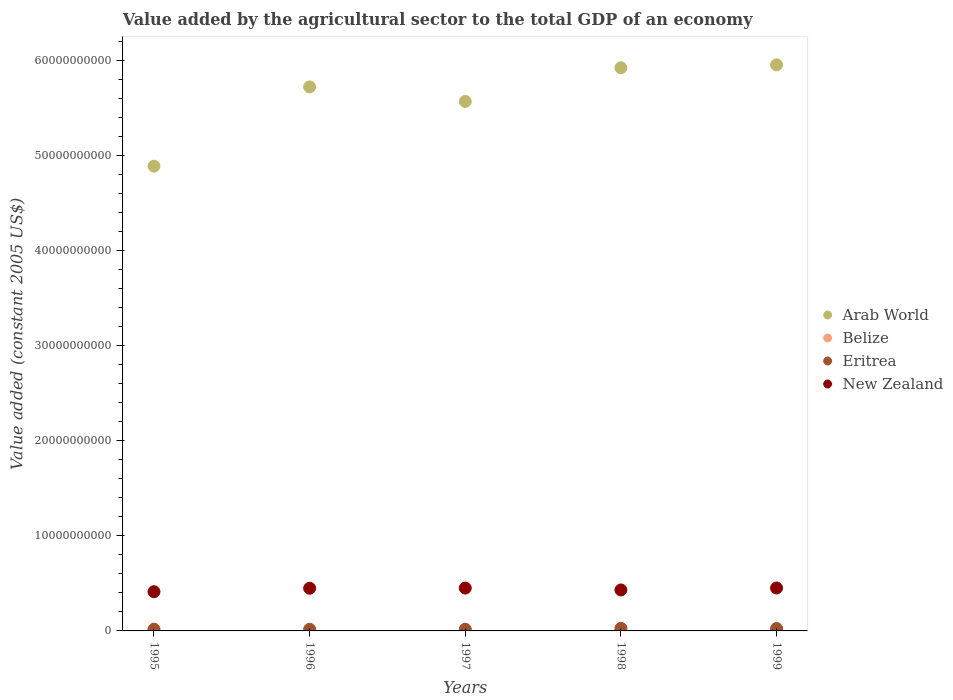How many different coloured dotlines are there?
Your response must be concise. 4. Is the number of dotlines equal to the number of legend labels?
Offer a very short reply. Yes. What is the value added by the agricultural sector in Arab World in 1996?
Offer a terse response. 5.73e+1. Across all years, what is the maximum value added by the agricultural sector in New Zealand?
Keep it short and to the point. 4.52e+09. Across all years, what is the minimum value added by the agricultural sector in Belize?
Your answer should be compact. 6.53e+07. In which year was the value added by the agricultural sector in Belize minimum?
Make the answer very short. 1995. What is the total value added by the agricultural sector in Eritrea in the graph?
Ensure brevity in your answer.  1.06e+09. What is the difference between the value added by the agricultural sector in Belize in 1996 and that in 1999?
Provide a short and direct response. -1.47e+07. What is the difference between the value added by the agricultural sector in New Zealand in 1998 and the value added by the agricultural sector in Arab World in 1999?
Give a very brief answer. -5.53e+1. What is the average value added by the agricultural sector in Arab World per year?
Your answer should be very brief. 5.62e+1. In the year 1998, what is the difference between the value added by the agricultural sector in Eritrea and value added by the agricultural sector in New Zealand?
Offer a terse response. -4.04e+09. What is the ratio of the value added by the agricultural sector in Eritrea in 1996 to that in 1998?
Your answer should be compact. 0.63. Is the value added by the agricultural sector in Arab World in 1997 less than that in 1999?
Your answer should be compact. Yes. What is the difference between the highest and the second highest value added by the agricultural sector in Belize?
Offer a very short reply. 8.30e+06. What is the difference between the highest and the lowest value added by the agricultural sector in New Zealand?
Your response must be concise. 3.92e+08. Is the sum of the value added by the agricultural sector in New Zealand in 1996 and 1998 greater than the maximum value added by the agricultural sector in Belize across all years?
Your answer should be compact. Yes. Is the value added by the agricultural sector in New Zealand strictly greater than the value added by the agricultural sector in Eritrea over the years?
Give a very brief answer. Yes. How many dotlines are there?
Provide a succinct answer. 4. Does the graph contain grids?
Offer a terse response. No. Where does the legend appear in the graph?
Provide a short and direct response. Center right. How many legend labels are there?
Your response must be concise. 4. How are the legend labels stacked?
Make the answer very short. Vertical. What is the title of the graph?
Your answer should be very brief. Value added by the agricultural sector to the total GDP of an economy. Does "Burundi" appear as one of the legend labels in the graph?
Provide a succinct answer. No. What is the label or title of the X-axis?
Ensure brevity in your answer.  Years. What is the label or title of the Y-axis?
Your answer should be compact. Value added (constant 2005 US$). What is the Value added (constant 2005 US$) in Arab World in 1995?
Your answer should be very brief. 4.89e+1. What is the Value added (constant 2005 US$) in Belize in 1995?
Provide a succinct answer. 6.53e+07. What is the Value added (constant 2005 US$) in Eritrea in 1995?
Provide a succinct answer. 1.85e+08. What is the Value added (constant 2005 US$) in New Zealand in 1995?
Give a very brief answer. 4.13e+09. What is the Value added (constant 2005 US$) of Arab World in 1996?
Provide a succinct answer. 5.73e+1. What is the Value added (constant 2005 US$) in Belize in 1996?
Offer a terse response. 7.01e+07. What is the Value added (constant 2005 US$) in Eritrea in 1996?
Give a very brief answer. 1.74e+08. What is the Value added (constant 2005 US$) in New Zealand in 1996?
Make the answer very short. 4.49e+09. What is the Value added (constant 2005 US$) in Arab World in 1997?
Keep it short and to the point. 5.57e+1. What is the Value added (constant 2005 US$) of Belize in 1997?
Your response must be concise. 7.47e+07. What is the Value added (constant 2005 US$) of Eritrea in 1997?
Give a very brief answer. 1.75e+08. What is the Value added (constant 2005 US$) in New Zealand in 1997?
Give a very brief answer. 4.51e+09. What is the Value added (constant 2005 US$) of Arab World in 1998?
Your response must be concise. 5.93e+1. What is the Value added (constant 2005 US$) in Belize in 1998?
Your answer should be very brief. 7.64e+07. What is the Value added (constant 2005 US$) in Eritrea in 1998?
Offer a terse response. 2.75e+08. What is the Value added (constant 2005 US$) in New Zealand in 1998?
Ensure brevity in your answer.  4.31e+09. What is the Value added (constant 2005 US$) of Arab World in 1999?
Provide a succinct answer. 5.96e+1. What is the Value added (constant 2005 US$) in Belize in 1999?
Provide a succinct answer. 8.47e+07. What is the Value added (constant 2005 US$) of Eritrea in 1999?
Provide a short and direct response. 2.54e+08. What is the Value added (constant 2005 US$) of New Zealand in 1999?
Provide a short and direct response. 4.52e+09. Across all years, what is the maximum Value added (constant 2005 US$) of Arab World?
Ensure brevity in your answer.  5.96e+1. Across all years, what is the maximum Value added (constant 2005 US$) in Belize?
Give a very brief answer. 8.47e+07. Across all years, what is the maximum Value added (constant 2005 US$) in Eritrea?
Provide a succinct answer. 2.75e+08. Across all years, what is the maximum Value added (constant 2005 US$) of New Zealand?
Offer a very short reply. 4.52e+09. Across all years, what is the minimum Value added (constant 2005 US$) in Arab World?
Give a very brief answer. 4.89e+1. Across all years, what is the minimum Value added (constant 2005 US$) of Belize?
Your response must be concise. 6.53e+07. Across all years, what is the minimum Value added (constant 2005 US$) in Eritrea?
Offer a very short reply. 1.74e+08. Across all years, what is the minimum Value added (constant 2005 US$) in New Zealand?
Your response must be concise. 4.13e+09. What is the total Value added (constant 2005 US$) in Arab World in the graph?
Provide a short and direct response. 2.81e+11. What is the total Value added (constant 2005 US$) in Belize in the graph?
Give a very brief answer. 3.71e+08. What is the total Value added (constant 2005 US$) of Eritrea in the graph?
Provide a short and direct response. 1.06e+09. What is the total Value added (constant 2005 US$) of New Zealand in the graph?
Keep it short and to the point. 2.20e+1. What is the difference between the Value added (constant 2005 US$) in Arab World in 1995 and that in 1996?
Offer a very short reply. -8.34e+09. What is the difference between the Value added (constant 2005 US$) in Belize in 1995 and that in 1996?
Keep it short and to the point. -4.76e+06. What is the difference between the Value added (constant 2005 US$) in Eritrea in 1995 and that in 1996?
Your answer should be very brief. 1.06e+07. What is the difference between the Value added (constant 2005 US$) in New Zealand in 1995 and that in 1996?
Your answer should be very brief. -3.64e+08. What is the difference between the Value added (constant 2005 US$) of Arab World in 1995 and that in 1997?
Your response must be concise. -6.81e+09. What is the difference between the Value added (constant 2005 US$) in Belize in 1995 and that in 1997?
Offer a very short reply. -9.42e+06. What is the difference between the Value added (constant 2005 US$) in Eritrea in 1995 and that in 1997?
Give a very brief answer. 9.75e+06. What is the difference between the Value added (constant 2005 US$) of New Zealand in 1995 and that in 1997?
Ensure brevity in your answer.  -3.82e+08. What is the difference between the Value added (constant 2005 US$) in Arab World in 1995 and that in 1998?
Make the answer very short. -1.04e+1. What is the difference between the Value added (constant 2005 US$) of Belize in 1995 and that in 1998?
Your answer should be compact. -1.11e+07. What is the difference between the Value added (constant 2005 US$) of Eritrea in 1995 and that in 1998?
Offer a very short reply. -9.05e+07. What is the difference between the Value added (constant 2005 US$) in New Zealand in 1995 and that in 1998?
Your answer should be compact. -1.86e+08. What is the difference between the Value added (constant 2005 US$) of Arab World in 1995 and that in 1999?
Provide a short and direct response. -1.07e+1. What is the difference between the Value added (constant 2005 US$) in Belize in 1995 and that in 1999?
Provide a short and direct response. -1.94e+07. What is the difference between the Value added (constant 2005 US$) of Eritrea in 1995 and that in 1999?
Provide a short and direct response. -6.95e+07. What is the difference between the Value added (constant 2005 US$) of New Zealand in 1995 and that in 1999?
Keep it short and to the point. -3.92e+08. What is the difference between the Value added (constant 2005 US$) in Arab World in 1996 and that in 1997?
Provide a short and direct response. 1.53e+09. What is the difference between the Value added (constant 2005 US$) in Belize in 1996 and that in 1997?
Keep it short and to the point. -4.65e+06. What is the difference between the Value added (constant 2005 US$) of Eritrea in 1996 and that in 1997?
Your answer should be compact. -8.89e+05. What is the difference between the Value added (constant 2005 US$) in New Zealand in 1996 and that in 1997?
Ensure brevity in your answer.  -1.73e+07. What is the difference between the Value added (constant 2005 US$) of Arab World in 1996 and that in 1998?
Your answer should be very brief. -2.02e+09. What is the difference between the Value added (constant 2005 US$) of Belize in 1996 and that in 1998?
Ensure brevity in your answer.  -6.36e+06. What is the difference between the Value added (constant 2005 US$) of Eritrea in 1996 and that in 1998?
Ensure brevity in your answer.  -1.01e+08. What is the difference between the Value added (constant 2005 US$) in New Zealand in 1996 and that in 1998?
Your answer should be very brief. 1.79e+08. What is the difference between the Value added (constant 2005 US$) in Arab World in 1996 and that in 1999?
Offer a very short reply. -2.32e+09. What is the difference between the Value added (constant 2005 US$) of Belize in 1996 and that in 1999?
Offer a terse response. -1.47e+07. What is the difference between the Value added (constant 2005 US$) in Eritrea in 1996 and that in 1999?
Ensure brevity in your answer.  -8.01e+07. What is the difference between the Value added (constant 2005 US$) of New Zealand in 1996 and that in 1999?
Your answer should be very brief. -2.74e+07. What is the difference between the Value added (constant 2005 US$) of Arab World in 1997 and that in 1998?
Ensure brevity in your answer.  -3.55e+09. What is the difference between the Value added (constant 2005 US$) of Belize in 1997 and that in 1998?
Offer a very short reply. -1.71e+06. What is the difference between the Value added (constant 2005 US$) of Eritrea in 1997 and that in 1998?
Ensure brevity in your answer.  -1.00e+08. What is the difference between the Value added (constant 2005 US$) of New Zealand in 1997 and that in 1998?
Your response must be concise. 1.96e+08. What is the difference between the Value added (constant 2005 US$) of Arab World in 1997 and that in 1999?
Provide a short and direct response. -3.86e+09. What is the difference between the Value added (constant 2005 US$) of Belize in 1997 and that in 1999?
Your answer should be very brief. -1.00e+07. What is the difference between the Value added (constant 2005 US$) in Eritrea in 1997 and that in 1999?
Your answer should be very brief. -7.92e+07. What is the difference between the Value added (constant 2005 US$) of New Zealand in 1997 and that in 1999?
Your answer should be compact. -1.00e+07. What is the difference between the Value added (constant 2005 US$) of Arab World in 1998 and that in 1999?
Provide a succinct answer. -3.03e+08. What is the difference between the Value added (constant 2005 US$) of Belize in 1998 and that in 1999?
Provide a succinct answer. -8.30e+06. What is the difference between the Value added (constant 2005 US$) in Eritrea in 1998 and that in 1999?
Your response must be concise. 2.11e+07. What is the difference between the Value added (constant 2005 US$) of New Zealand in 1998 and that in 1999?
Give a very brief answer. -2.06e+08. What is the difference between the Value added (constant 2005 US$) of Arab World in 1995 and the Value added (constant 2005 US$) of Belize in 1996?
Your answer should be very brief. 4.89e+1. What is the difference between the Value added (constant 2005 US$) in Arab World in 1995 and the Value added (constant 2005 US$) in Eritrea in 1996?
Ensure brevity in your answer.  4.87e+1. What is the difference between the Value added (constant 2005 US$) of Arab World in 1995 and the Value added (constant 2005 US$) of New Zealand in 1996?
Offer a very short reply. 4.44e+1. What is the difference between the Value added (constant 2005 US$) in Belize in 1995 and the Value added (constant 2005 US$) in Eritrea in 1996?
Your answer should be very brief. -1.09e+08. What is the difference between the Value added (constant 2005 US$) in Belize in 1995 and the Value added (constant 2005 US$) in New Zealand in 1996?
Your answer should be compact. -4.43e+09. What is the difference between the Value added (constant 2005 US$) in Eritrea in 1995 and the Value added (constant 2005 US$) in New Zealand in 1996?
Provide a short and direct response. -4.31e+09. What is the difference between the Value added (constant 2005 US$) of Arab World in 1995 and the Value added (constant 2005 US$) of Belize in 1997?
Ensure brevity in your answer.  4.88e+1. What is the difference between the Value added (constant 2005 US$) of Arab World in 1995 and the Value added (constant 2005 US$) of Eritrea in 1997?
Provide a short and direct response. 4.87e+1. What is the difference between the Value added (constant 2005 US$) in Arab World in 1995 and the Value added (constant 2005 US$) in New Zealand in 1997?
Ensure brevity in your answer.  4.44e+1. What is the difference between the Value added (constant 2005 US$) in Belize in 1995 and the Value added (constant 2005 US$) in Eritrea in 1997?
Give a very brief answer. -1.10e+08. What is the difference between the Value added (constant 2005 US$) of Belize in 1995 and the Value added (constant 2005 US$) of New Zealand in 1997?
Make the answer very short. -4.44e+09. What is the difference between the Value added (constant 2005 US$) in Eritrea in 1995 and the Value added (constant 2005 US$) in New Zealand in 1997?
Give a very brief answer. -4.32e+09. What is the difference between the Value added (constant 2005 US$) in Arab World in 1995 and the Value added (constant 2005 US$) in Belize in 1998?
Offer a terse response. 4.88e+1. What is the difference between the Value added (constant 2005 US$) in Arab World in 1995 and the Value added (constant 2005 US$) in Eritrea in 1998?
Make the answer very short. 4.86e+1. What is the difference between the Value added (constant 2005 US$) in Arab World in 1995 and the Value added (constant 2005 US$) in New Zealand in 1998?
Your answer should be compact. 4.46e+1. What is the difference between the Value added (constant 2005 US$) of Belize in 1995 and the Value added (constant 2005 US$) of Eritrea in 1998?
Provide a succinct answer. -2.10e+08. What is the difference between the Value added (constant 2005 US$) of Belize in 1995 and the Value added (constant 2005 US$) of New Zealand in 1998?
Your answer should be very brief. -4.25e+09. What is the difference between the Value added (constant 2005 US$) of Eritrea in 1995 and the Value added (constant 2005 US$) of New Zealand in 1998?
Offer a very short reply. -4.13e+09. What is the difference between the Value added (constant 2005 US$) of Arab World in 1995 and the Value added (constant 2005 US$) of Belize in 1999?
Make the answer very short. 4.88e+1. What is the difference between the Value added (constant 2005 US$) in Arab World in 1995 and the Value added (constant 2005 US$) in Eritrea in 1999?
Your answer should be very brief. 4.87e+1. What is the difference between the Value added (constant 2005 US$) of Arab World in 1995 and the Value added (constant 2005 US$) of New Zealand in 1999?
Keep it short and to the point. 4.44e+1. What is the difference between the Value added (constant 2005 US$) of Belize in 1995 and the Value added (constant 2005 US$) of Eritrea in 1999?
Your answer should be very brief. -1.89e+08. What is the difference between the Value added (constant 2005 US$) in Belize in 1995 and the Value added (constant 2005 US$) in New Zealand in 1999?
Keep it short and to the point. -4.45e+09. What is the difference between the Value added (constant 2005 US$) in Eritrea in 1995 and the Value added (constant 2005 US$) in New Zealand in 1999?
Provide a short and direct response. -4.33e+09. What is the difference between the Value added (constant 2005 US$) of Arab World in 1996 and the Value added (constant 2005 US$) of Belize in 1997?
Provide a short and direct response. 5.72e+1. What is the difference between the Value added (constant 2005 US$) in Arab World in 1996 and the Value added (constant 2005 US$) in Eritrea in 1997?
Your response must be concise. 5.71e+1. What is the difference between the Value added (constant 2005 US$) of Arab World in 1996 and the Value added (constant 2005 US$) of New Zealand in 1997?
Make the answer very short. 5.28e+1. What is the difference between the Value added (constant 2005 US$) of Belize in 1996 and the Value added (constant 2005 US$) of Eritrea in 1997?
Offer a very short reply. -1.05e+08. What is the difference between the Value added (constant 2005 US$) in Belize in 1996 and the Value added (constant 2005 US$) in New Zealand in 1997?
Ensure brevity in your answer.  -4.44e+09. What is the difference between the Value added (constant 2005 US$) in Eritrea in 1996 and the Value added (constant 2005 US$) in New Zealand in 1997?
Keep it short and to the point. -4.34e+09. What is the difference between the Value added (constant 2005 US$) of Arab World in 1996 and the Value added (constant 2005 US$) of Belize in 1998?
Offer a very short reply. 5.72e+1. What is the difference between the Value added (constant 2005 US$) in Arab World in 1996 and the Value added (constant 2005 US$) in Eritrea in 1998?
Give a very brief answer. 5.70e+1. What is the difference between the Value added (constant 2005 US$) of Arab World in 1996 and the Value added (constant 2005 US$) of New Zealand in 1998?
Make the answer very short. 5.29e+1. What is the difference between the Value added (constant 2005 US$) of Belize in 1996 and the Value added (constant 2005 US$) of Eritrea in 1998?
Offer a very short reply. -2.05e+08. What is the difference between the Value added (constant 2005 US$) of Belize in 1996 and the Value added (constant 2005 US$) of New Zealand in 1998?
Make the answer very short. -4.24e+09. What is the difference between the Value added (constant 2005 US$) in Eritrea in 1996 and the Value added (constant 2005 US$) in New Zealand in 1998?
Keep it short and to the point. -4.14e+09. What is the difference between the Value added (constant 2005 US$) in Arab World in 1996 and the Value added (constant 2005 US$) in Belize in 1999?
Your response must be concise. 5.72e+1. What is the difference between the Value added (constant 2005 US$) of Arab World in 1996 and the Value added (constant 2005 US$) of Eritrea in 1999?
Provide a succinct answer. 5.70e+1. What is the difference between the Value added (constant 2005 US$) in Arab World in 1996 and the Value added (constant 2005 US$) in New Zealand in 1999?
Give a very brief answer. 5.27e+1. What is the difference between the Value added (constant 2005 US$) of Belize in 1996 and the Value added (constant 2005 US$) of Eritrea in 1999?
Make the answer very short. -1.84e+08. What is the difference between the Value added (constant 2005 US$) in Belize in 1996 and the Value added (constant 2005 US$) in New Zealand in 1999?
Your response must be concise. -4.45e+09. What is the difference between the Value added (constant 2005 US$) in Eritrea in 1996 and the Value added (constant 2005 US$) in New Zealand in 1999?
Provide a short and direct response. -4.35e+09. What is the difference between the Value added (constant 2005 US$) in Arab World in 1997 and the Value added (constant 2005 US$) in Belize in 1998?
Your answer should be compact. 5.57e+1. What is the difference between the Value added (constant 2005 US$) in Arab World in 1997 and the Value added (constant 2005 US$) in Eritrea in 1998?
Offer a very short reply. 5.55e+1. What is the difference between the Value added (constant 2005 US$) in Arab World in 1997 and the Value added (constant 2005 US$) in New Zealand in 1998?
Provide a short and direct response. 5.14e+1. What is the difference between the Value added (constant 2005 US$) in Belize in 1997 and the Value added (constant 2005 US$) in Eritrea in 1998?
Provide a succinct answer. -2.00e+08. What is the difference between the Value added (constant 2005 US$) of Belize in 1997 and the Value added (constant 2005 US$) of New Zealand in 1998?
Provide a succinct answer. -4.24e+09. What is the difference between the Value added (constant 2005 US$) in Eritrea in 1997 and the Value added (constant 2005 US$) in New Zealand in 1998?
Offer a very short reply. -4.14e+09. What is the difference between the Value added (constant 2005 US$) in Arab World in 1997 and the Value added (constant 2005 US$) in Belize in 1999?
Give a very brief answer. 5.56e+1. What is the difference between the Value added (constant 2005 US$) of Arab World in 1997 and the Value added (constant 2005 US$) of Eritrea in 1999?
Make the answer very short. 5.55e+1. What is the difference between the Value added (constant 2005 US$) in Arab World in 1997 and the Value added (constant 2005 US$) in New Zealand in 1999?
Ensure brevity in your answer.  5.12e+1. What is the difference between the Value added (constant 2005 US$) in Belize in 1997 and the Value added (constant 2005 US$) in Eritrea in 1999?
Make the answer very short. -1.79e+08. What is the difference between the Value added (constant 2005 US$) of Belize in 1997 and the Value added (constant 2005 US$) of New Zealand in 1999?
Provide a short and direct response. -4.44e+09. What is the difference between the Value added (constant 2005 US$) in Eritrea in 1997 and the Value added (constant 2005 US$) in New Zealand in 1999?
Your answer should be compact. -4.34e+09. What is the difference between the Value added (constant 2005 US$) in Arab World in 1998 and the Value added (constant 2005 US$) in Belize in 1999?
Provide a succinct answer. 5.92e+1. What is the difference between the Value added (constant 2005 US$) of Arab World in 1998 and the Value added (constant 2005 US$) of Eritrea in 1999?
Your answer should be very brief. 5.90e+1. What is the difference between the Value added (constant 2005 US$) of Arab World in 1998 and the Value added (constant 2005 US$) of New Zealand in 1999?
Make the answer very short. 5.48e+1. What is the difference between the Value added (constant 2005 US$) of Belize in 1998 and the Value added (constant 2005 US$) of Eritrea in 1999?
Provide a succinct answer. -1.78e+08. What is the difference between the Value added (constant 2005 US$) of Belize in 1998 and the Value added (constant 2005 US$) of New Zealand in 1999?
Ensure brevity in your answer.  -4.44e+09. What is the difference between the Value added (constant 2005 US$) of Eritrea in 1998 and the Value added (constant 2005 US$) of New Zealand in 1999?
Provide a short and direct response. -4.24e+09. What is the average Value added (constant 2005 US$) in Arab World per year?
Offer a terse response. 5.62e+1. What is the average Value added (constant 2005 US$) in Belize per year?
Your answer should be compact. 7.42e+07. What is the average Value added (constant 2005 US$) in Eritrea per year?
Provide a short and direct response. 2.13e+08. What is the average Value added (constant 2005 US$) of New Zealand per year?
Offer a very short reply. 4.39e+09. In the year 1995, what is the difference between the Value added (constant 2005 US$) in Arab World and Value added (constant 2005 US$) in Belize?
Provide a succinct answer. 4.89e+1. In the year 1995, what is the difference between the Value added (constant 2005 US$) in Arab World and Value added (constant 2005 US$) in Eritrea?
Keep it short and to the point. 4.87e+1. In the year 1995, what is the difference between the Value added (constant 2005 US$) of Arab World and Value added (constant 2005 US$) of New Zealand?
Offer a very short reply. 4.48e+1. In the year 1995, what is the difference between the Value added (constant 2005 US$) of Belize and Value added (constant 2005 US$) of Eritrea?
Provide a succinct answer. -1.19e+08. In the year 1995, what is the difference between the Value added (constant 2005 US$) in Belize and Value added (constant 2005 US$) in New Zealand?
Keep it short and to the point. -4.06e+09. In the year 1995, what is the difference between the Value added (constant 2005 US$) of Eritrea and Value added (constant 2005 US$) of New Zealand?
Provide a short and direct response. -3.94e+09. In the year 1996, what is the difference between the Value added (constant 2005 US$) in Arab World and Value added (constant 2005 US$) in Belize?
Your response must be concise. 5.72e+1. In the year 1996, what is the difference between the Value added (constant 2005 US$) in Arab World and Value added (constant 2005 US$) in Eritrea?
Ensure brevity in your answer.  5.71e+1. In the year 1996, what is the difference between the Value added (constant 2005 US$) in Arab World and Value added (constant 2005 US$) in New Zealand?
Offer a terse response. 5.28e+1. In the year 1996, what is the difference between the Value added (constant 2005 US$) in Belize and Value added (constant 2005 US$) in Eritrea?
Make the answer very short. -1.04e+08. In the year 1996, what is the difference between the Value added (constant 2005 US$) of Belize and Value added (constant 2005 US$) of New Zealand?
Ensure brevity in your answer.  -4.42e+09. In the year 1996, what is the difference between the Value added (constant 2005 US$) in Eritrea and Value added (constant 2005 US$) in New Zealand?
Keep it short and to the point. -4.32e+09. In the year 1997, what is the difference between the Value added (constant 2005 US$) in Arab World and Value added (constant 2005 US$) in Belize?
Offer a terse response. 5.57e+1. In the year 1997, what is the difference between the Value added (constant 2005 US$) of Arab World and Value added (constant 2005 US$) of Eritrea?
Your response must be concise. 5.56e+1. In the year 1997, what is the difference between the Value added (constant 2005 US$) of Arab World and Value added (constant 2005 US$) of New Zealand?
Offer a very short reply. 5.12e+1. In the year 1997, what is the difference between the Value added (constant 2005 US$) of Belize and Value added (constant 2005 US$) of Eritrea?
Make the answer very short. -1.00e+08. In the year 1997, what is the difference between the Value added (constant 2005 US$) of Belize and Value added (constant 2005 US$) of New Zealand?
Your answer should be compact. -4.43e+09. In the year 1997, what is the difference between the Value added (constant 2005 US$) of Eritrea and Value added (constant 2005 US$) of New Zealand?
Provide a short and direct response. -4.33e+09. In the year 1998, what is the difference between the Value added (constant 2005 US$) of Arab World and Value added (constant 2005 US$) of Belize?
Provide a succinct answer. 5.92e+1. In the year 1998, what is the difference between the Value added (constant 2005 US$) in Arab World and Value added (constant 2005 US$) in Eritrea?
Ensure brevity in your answer.  5.90e+1. In the year 1998, what is the difference between the Value added (constant 2005 US$) in Arab World and Value added (constant 2005 US$) in New Zealand?
Provide a short and direct response. 5.50e+1. In the year 1998, what is the difference between the Value added (constant 2005 US$) in Belize and Value added (constant 2005 US$) in Eritrea?
Provide a short and direct response. -1.99e+08. In the year 1998, what is the difference between the Value added (constant 2005 US$) in Belize and Value added (constant 2005 US$) in New Zealand?
Ensure brevity in your answer.  -4.24e+09. In the year 1998, what is the difference between the Value added (constant 2005 US$) of Eritrea and Value added (constant 2005 US$) of New Zealand?
Your response must be concise. -4.04e+09. In the year 1999, what is the difference between the Value added (constant 2005 US$) of Arab World and Value added (constant 2005 US$) of Belize?
Ensure brevity in your answer.  5.95e+1. In the year 1999, what is the difference between the Value added (constant 2005 US$) of Arab World and Value added (constant 2005 US$) of Eritrea?
Offer a terse response. 5.93e+1. In the year 1999, what is the difference between the Value added (constant 2005 US$) of Arab World and Value added (constant 2005 US$) of New Zealand?
Your answer should be compact. 5.51e+1. In the year 1999, what is the difference between the Value added (constant 2005 US$) of Belize and Value added (constant 2005 US$) of Eritrea?
Offer a very short reply. -1.69e+08. In the year 1999, what is the difference between the Value added (constant 2005 US$) of Belize and Value added (constant 2005 US$) of New Zealand?
Your answer should be compact. -4.43e+09. In the year 1999, what is the difference between the Value added (constant 2005 US$) of Eritrea and Value added (constant 2005 US$) of New Zealand?
Offer a terse response. -4.27e+09. What is the ratio of the Value added (constant 2005 US$) in Arab World in 1995 to that in 1996?
Make the answer very short. 0.85. What is the ratio of the Value added (constant 2005 US$) in Belize in 1995 to that in 1996?
Your answer should be compact. 0.93. What is the ratio of the Value added (constant 2005 US$) of Eritrea in 1995 to that in 1996?
Provide a succinct answer. 1.06. What is the ratio of the Value added (constant 2005 US$) in New Zealand in 1995 to that in 1996?
Ensure brevity in your answer.  0.92. What is the ratio of the Value added (constant 2005 US$) in Arab World in 1995 to that in 1997?
Offer a very short reply. 0.88. What is the ratio of the Value added (constant 2005 US$) in Belize in 1995 to that in 1997?
Give a very brief answer. 0.87. What is the ratio of the Value added (constant 2005 US$) of Eritrea in 1995 to that in 1997?
Offer a terse response. 1.06. What is the ratio of the Value added (constant 2005 US$) in New Zealand in 1995 to that in 1997?
Your answer should be compact. 0.92. What is the ratio of the Value added (constant 2005 US$) of Arab World in 1995 to that in 1998?
Provide a short and direct response. 0.83. What is the ratio of the Value added (constant 2005 US$) in Belize in 1995 to that in 1998?
Keep it short and to the point. 0.85. What is the ratio of the Value added (constant 2005 US$) in Eritrea in 1995 to that in 1998?
Your answer should be very brief. 0.67. What is the ratio of the Value added (constant 2005 US$) of Arab World in 1995 to that in 1999?
Your answer should be compact. 0.82. What is the ratio of the Value added (constant 2005 US$) of Belize in 1995 to that in 1999?
Ensure brevity in your answer.  0.77. What is the ratio of the Value added (constant 2005 US$) in Eritrea in 1995 to that in 1999?
Ensure brevity in your answer.  0.73. What is the ratio of the Value added (constant 2005 US$) in New Zealand in 1995 to that in 1999?
Make the answer very short. 0.91. What is the ratio of the Value added (constant 2005 US$) in Arab World in 1996 to that in 1997?
Give a very brief answer. 1.03. What is the ratio of the Value added (constant 2005 US$) in Belize in 1996 to that in 1997?
Ensure brevity in your answer.  0.94. What is the ratio of the Value added (constant 2005 US$) of New Zealand in 1996 to that in 1997?
Offer a very short reply. 1. What is the ratio of the Value added (constant 2005 US$) of Arab World in 1996 to that in 1998?
Offer a very short reply. 0.97. What is the ratio of the Value added (constant 2005 US$) in Belize in 1996 to that in 1998?
Your response must be concise. 0.92. What is the ratio of the Value added (constant 2005 US$) in Eritrea in 1996 to that in 1998?
Ensure brevity in your answer.  0.63. What is the ratio of the Value added (constant 2005 US$) of New Zealand in 1996 to that in 1998?
Offer a very short reply. 1.04. What is the ratio of the Value added (constant 2005 US$) of Arab World in 1996 to that in 1999?
Provide a succinct answer. 0.96. What is the ratio of the Value added (constant 2005 US$) in Belize in 1996 to that in 1999?
Your response must be concise. 0.83. What is the ratio of the Value added (constant 2005 US$) of Eritrea in 1996 to that in 1999?
Make the answer very short. 0.68. What is the ratio of the Value added (constant 2005 US$) in New Zealand in 1996 to that in 1999?
Provide a succinct answer. 0.99. What is the ratio of the Value added (constant 2005 US$) of Arab World in 1997 to that in 1998?
Keep it short and to the point. 0.94. What is the ratio of the Value added (constant 2005 US$) in Belize in 1997 to that in 1998?
Offer a terse response. 0.98. What is the ratio of the Value added (constant 2005 US$) of Eritrea in 1997 to that in 1998?
Your answer should be very brief. 0.64. What is the ratio of the Value added (constant 2005 US$) in New Zealand in 1997 to that in 1998?
Ensure brevity in your answer.  1.05. What is the ratio of the Value added (constant 2005 US$) in Arab World in 1997 to that in 1999?
Give a very brief answer. 0.94. What is the ratio of the Value added (constant 2005 US$) of Belize in 1997 to that in 1999?
Give a very brief answer. 0.88. What is the ratio of the Value added (constant 2005 US$) in Eritrea in 1997 to that in 1999?
Your answer should be very brief. 0.69. What is the ratio of the Value added (constant 2005 US$) in New Zealand in 1997 to that in 1999?
Give a very brief answer. 1. What is the ratio of the Value added (constant 2005 US$) in Belize in 1998 to that in 1999?
Provide a short and direct response. 0.9. What is the ratio of the Value added (constant 2005 US$) in Eritrea in 1998 to that in 1999?
Your answer should be compact. 1.08. What is the ratio of the Value added (constant 2005 US$) of New Zealand in 1998 to that in 1999?
Provide a succinct answer. 0.95. What is the difference between the highest and the second highest Value added (constant 2005 US$) of Arab World?
Give a very brief answer. 3.03e+08. What is the difference between the highest and the second highest Value added (constant 2005 US$) of Belize?
Provide a succinct answer. 8.30e+06. What is the difference between the highest and the second highest Value added (constant 2005 US$) of Eritrea?
Your answer should be compact. 2.11e+07. What is the difference between the highest and the second highest Value added (constant 2005 US$) in New Zealand?
Provide a short and direct response. 1.00e+07. What is the difference between the highest and the lowest Value added (constant 2005 US$) in Arab World?
Provide a short and direct response. 1.07e+1. What is the difference between the highest and the lowest Value added (constant 2005 US$) in Belize?
Offer a terse response. 1.94e+07. What is the difference between the highest and the lowest Value added (constant 2005 US$) of Eritrea?
Keep it short and to the point. 1.01e+08. What is the difference between the highest and the lowest Value added (constant 2005 US$) in New Zealand?
Provide a short and direct response. 3.92e+08. 